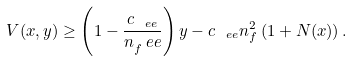<formula> <loc_0><loc_0><loc_500><loc_500>V ( x , y ) \geq \left ( 1 - \frac { c _ { \ e e } } { n _ { f } ^ { \ } e e } \right ) y - c _ { \ e e } n _ { f } ^ { 2 } \left ( 1 + N ( x ) \right ) .</formula> 